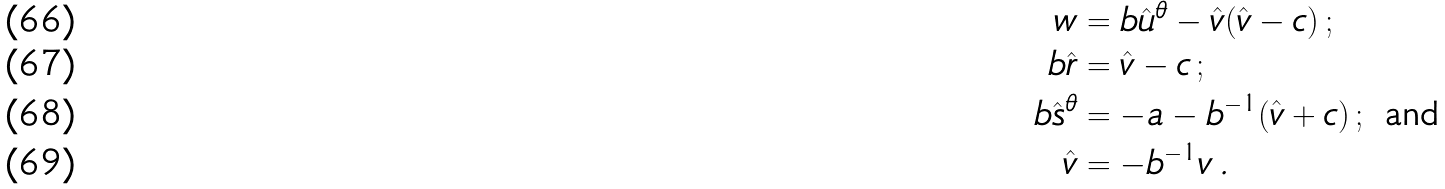<formula> <loc_0><loc_0><loc_500><loc_500>w & = b \hat { u } ^ { \theta } - \hat { v } ( \hat { v } - c ) \, ; \\ b \hat { r } & = \hat { v } - c \, ; \\ b \hat { s } ^ { \theta } & = - a - b ^ { - 1 } ( \hat { v } + c ) \, ; \text { and} \\ \hat { v } & = - b ^ { - 1 } v \, .</formula> 